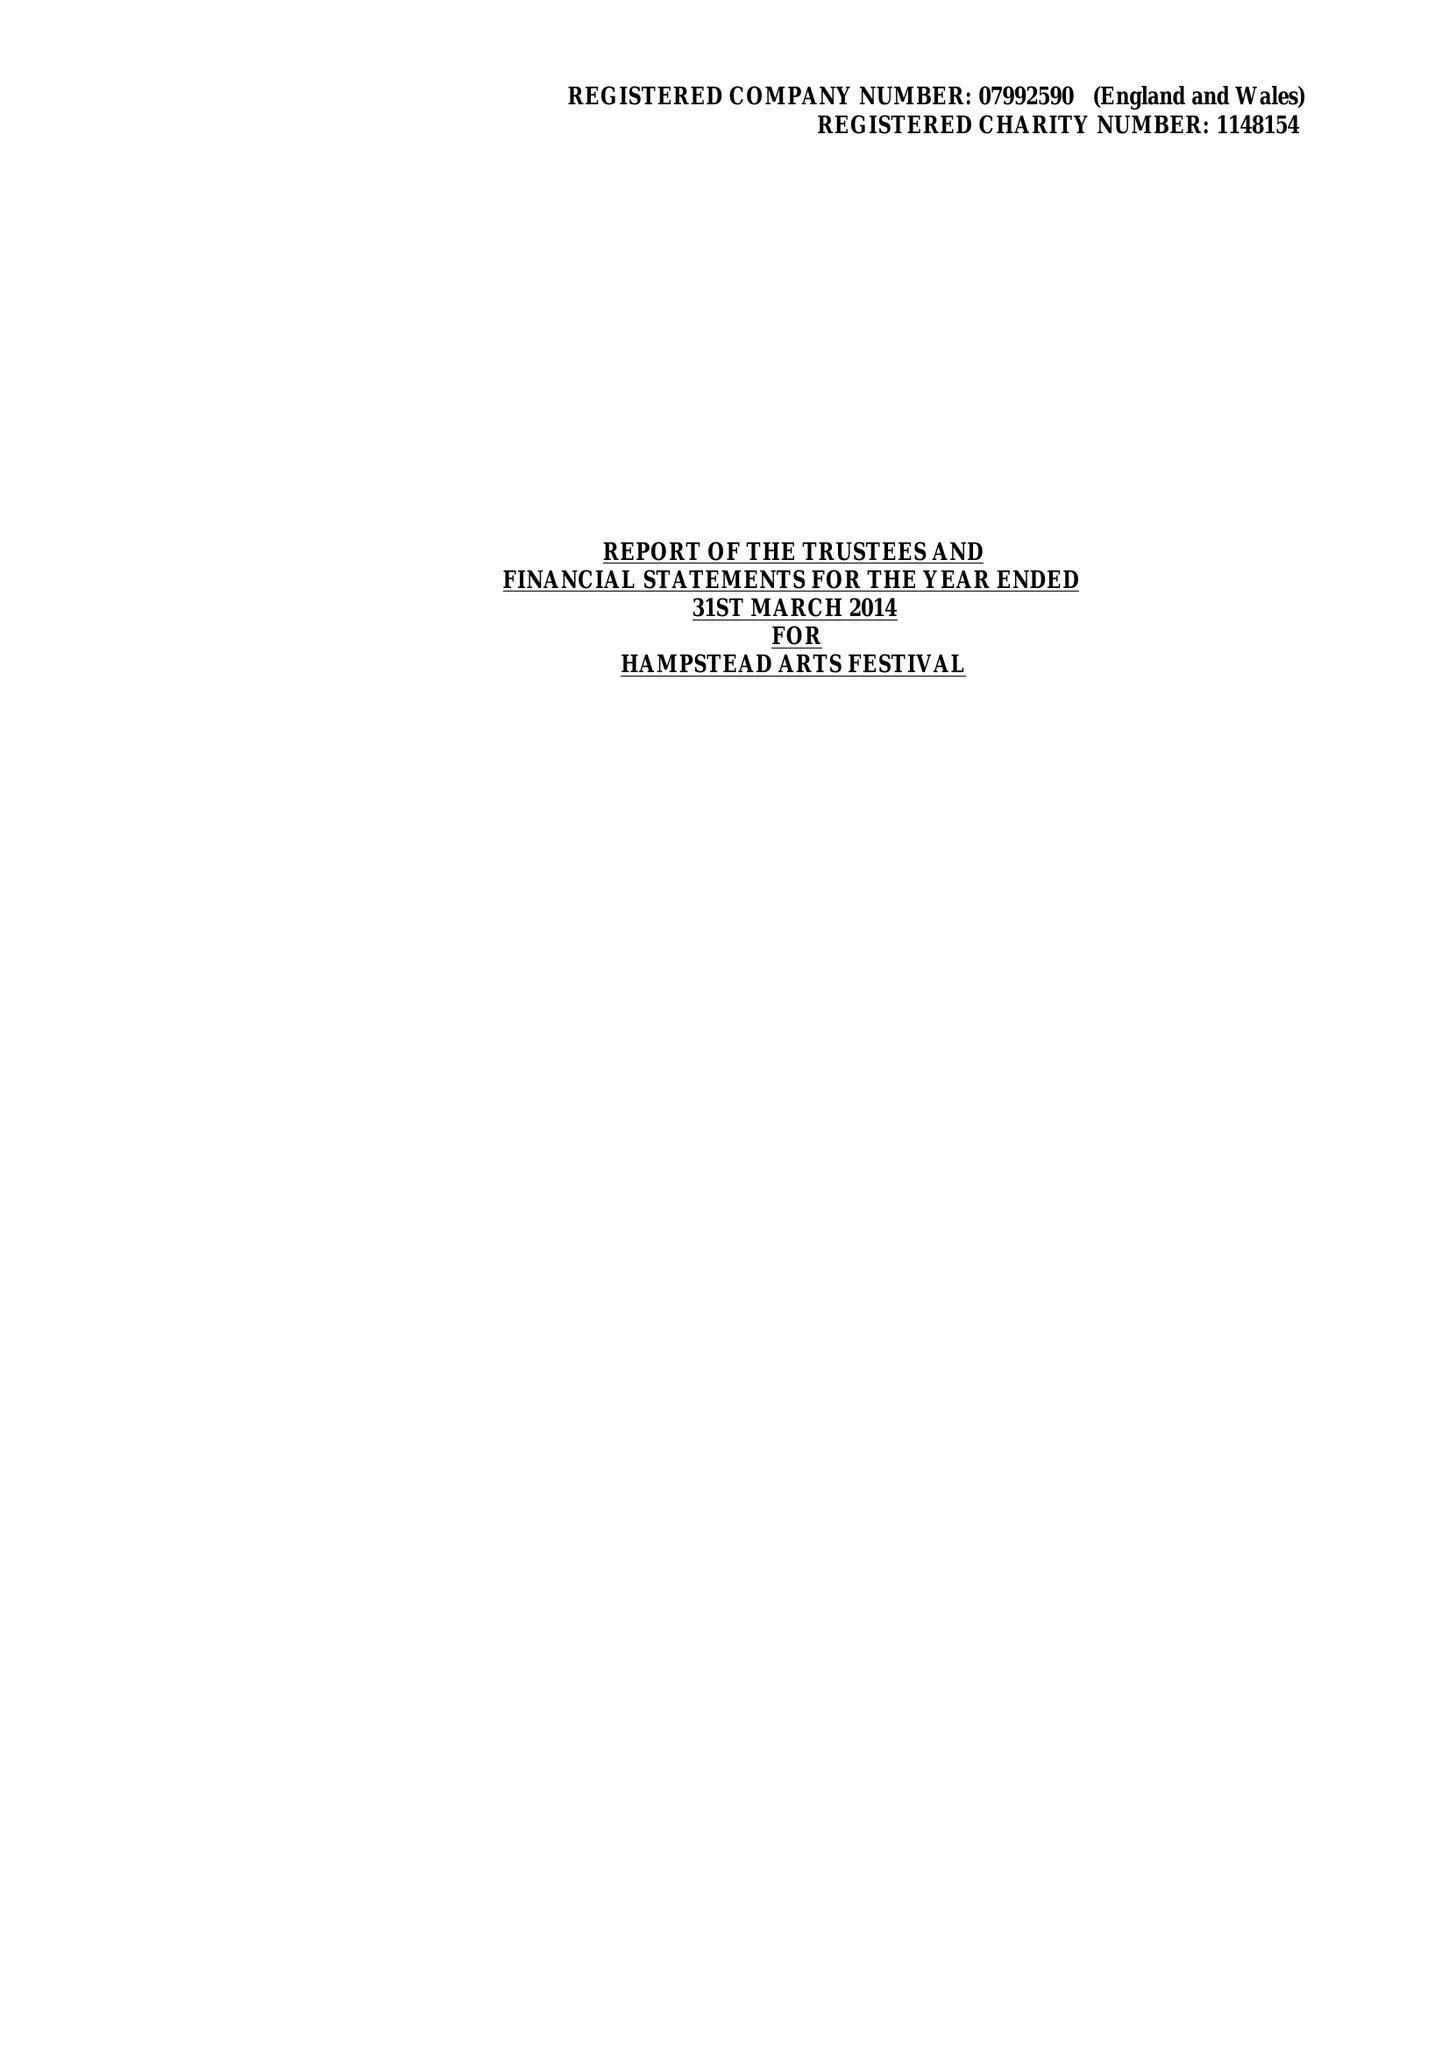What is the value for the charity_number?
Answer the question using a single word or phrase. 1148154 